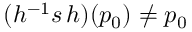Convert formula to latex. <formula><loc_0><loc_0><loc_500><loc_500>( h ^ { - 1 } s \, h ) ( p _ { 0 } ) \neq p _ { 0 }</formula> 